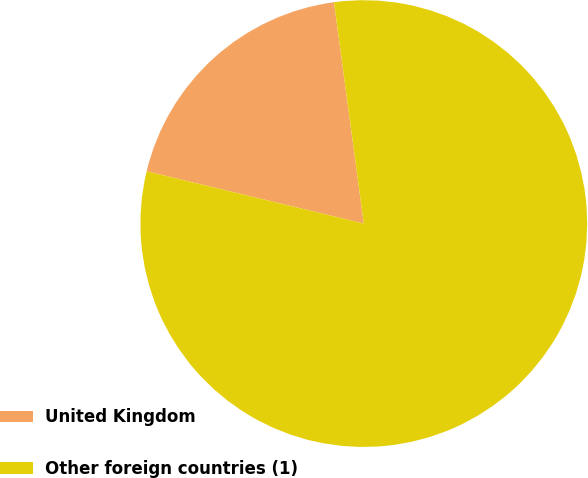Convert chart to OTSL. <chart><loc_0><loc_0><loc_500><loc_500><pie_chart><fcel>United Kingdom<fcel>Other foreign countries (1)<nl><fcel>19.11%<fcel>80.89%<nl></chart> 